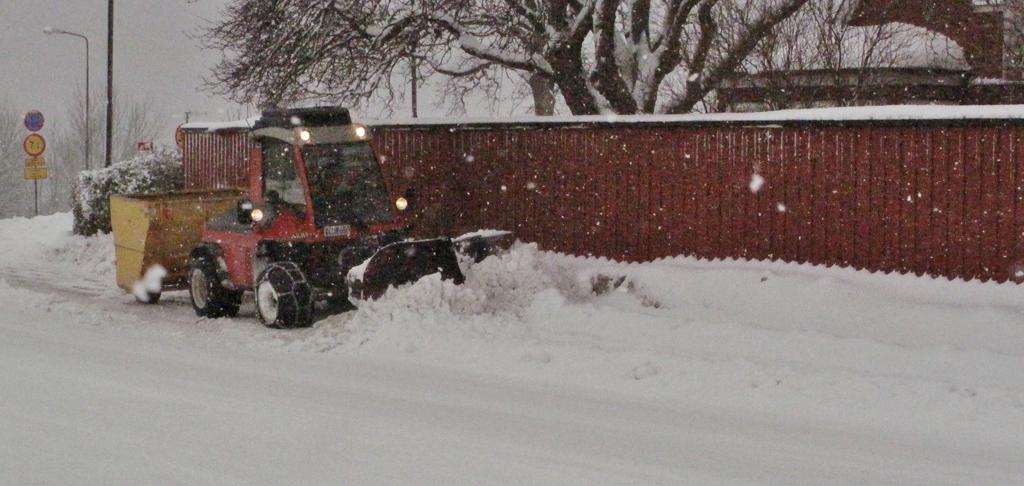What is the main feature of the image? There is a road in the image. How is the road affected by the weather? The road is covered with snow. What is present on the road? There is a vehicle on the road. What is located beside the vehicle? There is a wall beside the vehicle. What can be seen in the distance in the image? There are trees in the background of the image. What type of government is depicted in the image? There is no depiction of a government in the image; it features a snow-covered road, a vehicle, a wall, and trees in the background. 